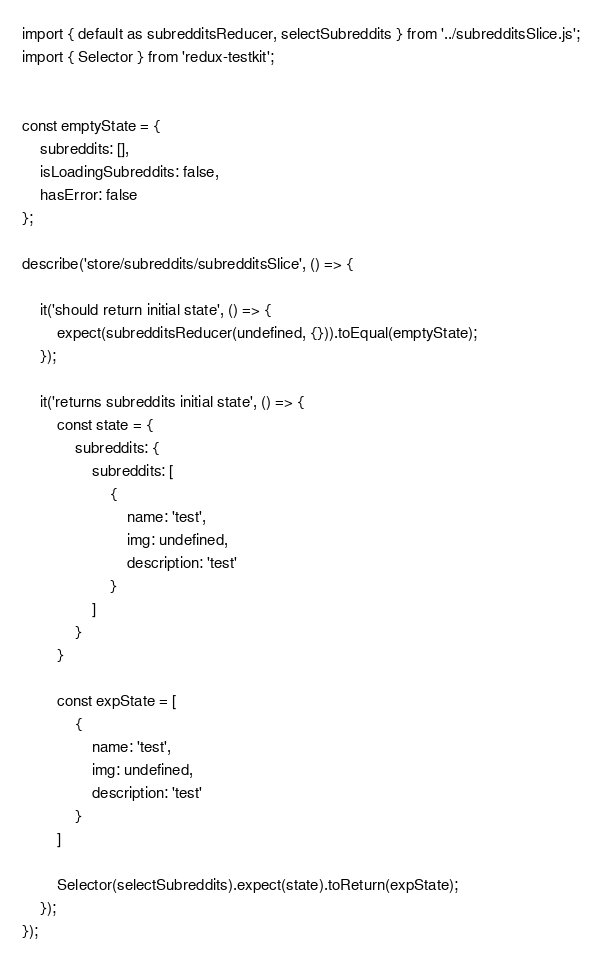Convert code to text. <code><loc_0><loc_0><loc_500><loc_500><_JavaScript_>import { default as subredditsReducer, selectSubreddits } from '../subredditsSlice.js';
import { Selector } from 'redux-testkit';


const emptyState = {
	subreddits: [],
    isLoadingSubreddits: false,
    hasError: false
};

describe('store/subreddits/subredditsSlice', () => {

	it('should return initial state', () => {
		expect(subredditsReducer(undefined, {})).toEqual(emptyState);
	});

	it('returns subreddits initial state', () => {
		const state = {
			subreddits: {
				subreddits: [
					{
						name: 'test',
						img: undefined,
						description: 'test'
					}
				]
			}
		}

		const expState = [
			{
				name: 'test',
				img: undefined,
				description: 'test'
			}
		]

		Selector(selectSubreddits).expect(state).toReturn(expState);
	});
});
</code> 